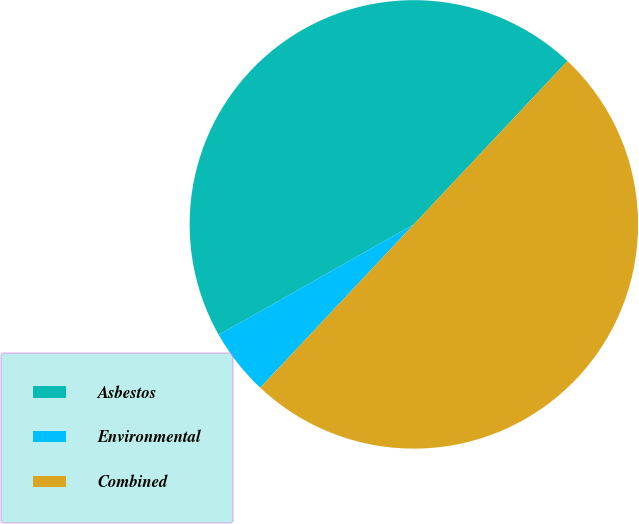Convert chart. <chart><loc_0><loc_0><loc_500><loc_500><pie_chart><fcel>Asbestos<fcel>Environmental<fcel>Combined<nl><fcel>45.21%<fcel>4.79%<fcel>50.0%<nl></chart> 